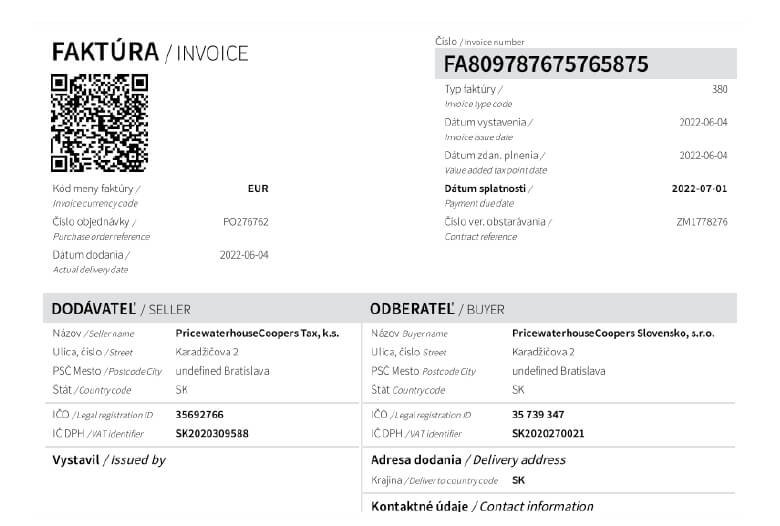Extract all the relevant billing information **Invoice number:** FA809787675765875
**Invoice date:** 2022-06-04
**Due date:** 2022-07-01
**Amount due:** 35 739.34 EUR
**Invoicee:**
PricewaterhouseCoopers Slovensko, s.r.o.
Karadžičova 2
812 36 Bratislava
Slovakia
**Biller:**
PricewaterhouseCoopers Tax, k.s.
Karadžičova 2
812 36 Bratislava
Slovakia 